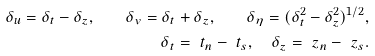Convert formula to latex. <formula><loc_0><loc_0><loc_500><loc_500>\delta _ { u } = \delta _ { t } - \delta _ { z } , \quad \delta _ { v } = \delta _ { t } + \delta _ { z } , \quad \delta _ { \eta } = ( \delta _ { t } ^ { 2 } - \delta _ { z } ^ { 2 } ) ^ { 1 / 2 } , \\ \delta _ { t } = \ t _ { n } - \ t _ { s } , \quad \delta _ { z } = \ z _ { n } - \ z _ { s } .</formula> 